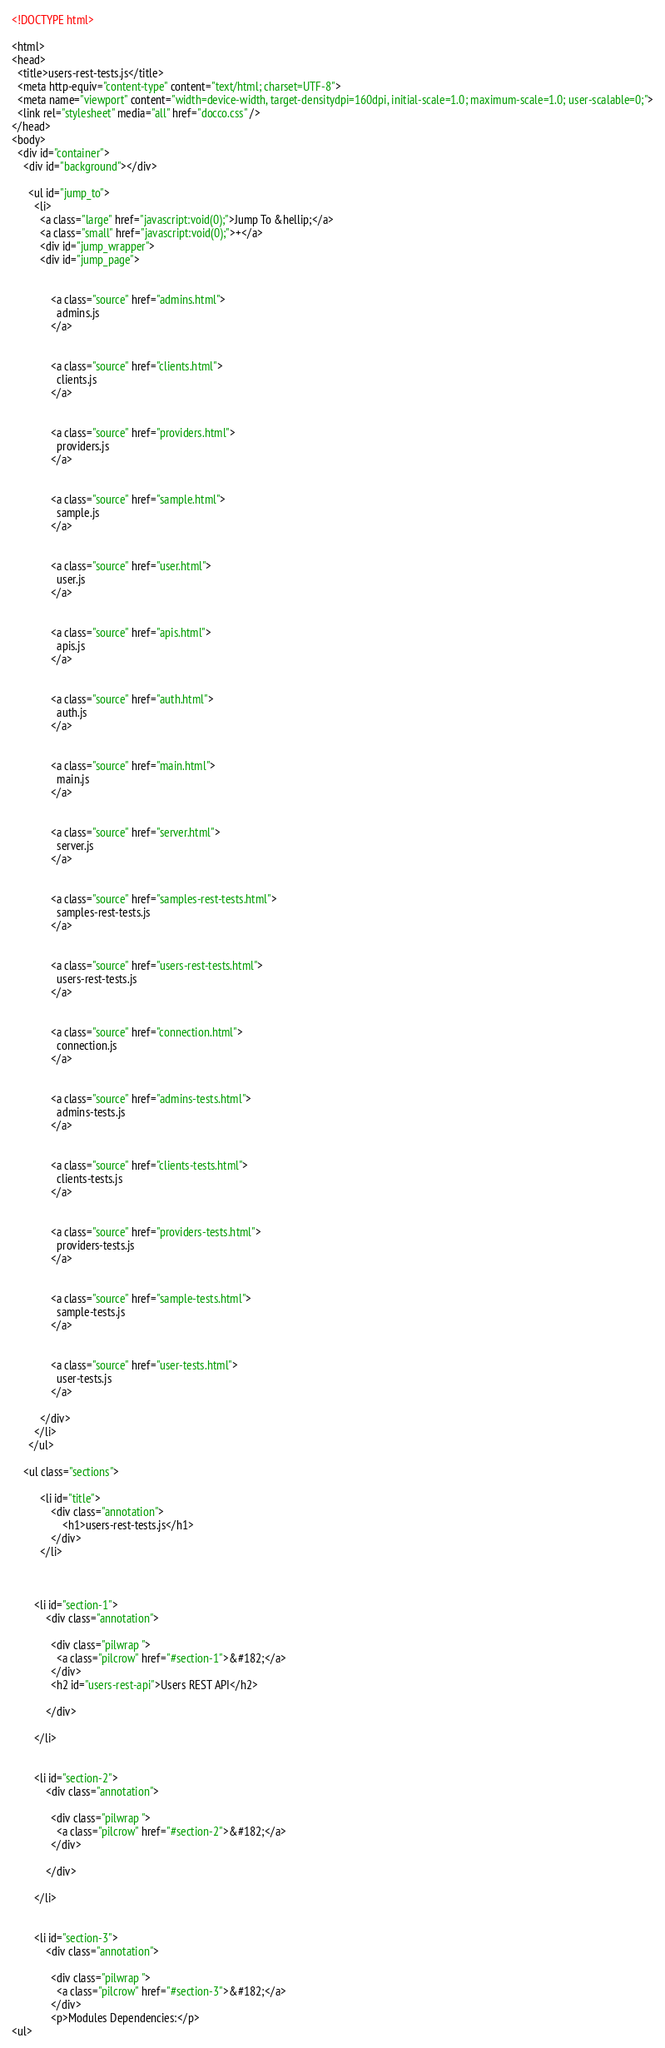Convert code to text. <code><loc_0><loc_0><loc_500><loc_500><_HTML_><!DOCTYPE html>

<html>
<head>
  <title>users-rest-tests.js</title>
  <meta http-equiv="content-type" content="text/html; charset=UTF-8">
  <meta name="viewport" content="width=device-width, target-densitydpi=160dpi, initial-scale=1.0; maximum-scale=1.0; user-scalable=0;">
  <link rel="stylesheet" media="all" href="docco.css" />
</head>
<body>
  <div id="container">
    <div id="background"></div>
    
      <ul id="jump_to">
        <li>
          <a class="large" href="javascript:void(0);">Jump To &hellip;</a>
          <a class="small" href="javascript:void(0);">+</a>
          <div id="jump_wrapper">
          <div id="jump_page">
            
              
              <a class="source" href="admins.html">
                admins.js
              </a>
            
              
              <a class="source" href="clients.html">
                clients.js
              </a>
            
              
              <a class="source" href="providers.html">
                providers.js
              </a>
            
              
              <a class="source" href="sample.html">
                sample.js
              </a>
            
              
              <a class="source" href="user.html">
                user.js
              </a>
            
              
              <a class="source" href="apis.html">
                apis.js
              </a>
            
              
              <a class="source" href="auth.html">
                auth.js
              </a>
            
              
              <a class="source" href="main.html">
                main.js
              </a>
            
              
              <a class="source" href="server.html">
                server.js
              </a>
            
              
              <a class="source" href="samples-rest-tests.html">
                samples-rest-tests.js
              </a>
            
              
              <a class="source" href="users-rest-tests.html">
                users-rest-tests.js
              </a>
            
              
              <a class="source" href="connection.html">
                connection.js
              </a>
            
              
              <a class="source" href="admins-tests.html">
                admins-tests.js
              </a>
            
              
              <a class="source" href="clients-tests.html">
                clients-tests.js
              </a>
            
              
              <a class="source" href="providers-tests.html">
                providers-tests.js
              </a>
            
              
              <a class="source" href="sample-tests.html">
                sample-tests.js
              </a>
            
              
              <a class="source" href="user-tests.html">
                user-tests.js
              </a>
            
          </div>
        </li>
      </ul>
    
    <ul class="sections">
        
          <li id="title">
              <div class="annotation">
                  <h1>users-rest-tests.js</h1>
              </div>
          </li>
        
        
        
        <li id="section-1">
            <div class="annotation">
              
              <div class="pilwrap ">
                <a class="pilcrow" href="#section-1">&#182;</a>
              </div>
              <h2 id="users-rest-api">Users REST API</h2>

            </div>
            
        </li>
        
        
        <li id="section-2">
            <div class="annotation">
              
              <div class="pilwrap ">
                <a class="pilcrow" href="#section-2">&#182;</a>
              </div>
              
            </div>
            
        </li>
        
        
        <li id="section-3">
            <div class="annotation">
              
              <div class="pilwrap ">
                <a class="pilcrow" href="#section-3">&#182;</a>
              </div>
              <p>Modules Dependencies:</p>
<ul></code> 